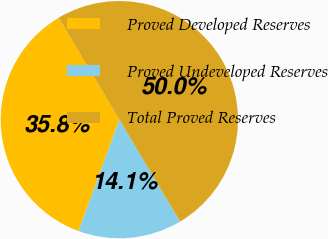<chart> <loc_0><loc_0><loc_500><loc_500><pie_chart><fcel>Proved Developed Reserves<fcel>Proved Undeveloped Reserves<fcel>Total Proved Reserves<nl><fcel>35.85%<fcel>14.15%<fcel>50.0%<nl></chart> 